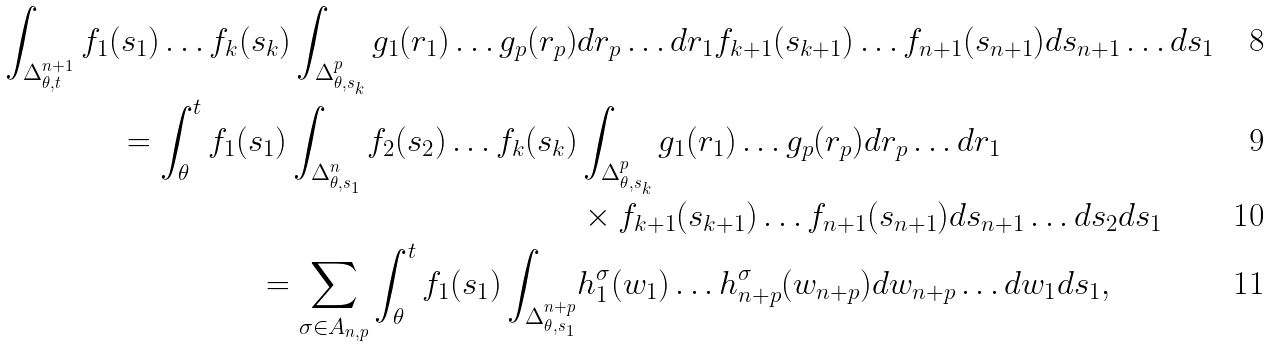Convert formula to latex. <formula><loc_0><loc_0><loc_500><loc_500>\int _ { \Delta _ { \theta , t } ^ { n + 1 } } f _ { 1 } ( s _ { 1 } ) \dots f _ { k } ( s _ { k } ) \int _ { \Delta _ { \theta , s _ { k } } ^ { p } } g _ { 1 } ( r _ { 1 } ) \dots g _ { p } ( r _ { p } ) & d r _ { p } \dots d r _ { 1 } f _ { k + 1 } ( s _ { k + 1 } ) \dots f _ { n + 1 } ( s _ { n + 1 } ) d s _ { n + 1 } \dots d s _ { 1 } \\ = \int _ { \theta } ^ { t } f _ { 1 } ( s _ { 1 } ) \int _ { \Delta _ { \theta , s _ { 1 } } ^ { n } } f _ { 2 } ( s _ { 2 } ) \dots f _ { k } ( s _ { k } ) & \int _ { \Delta _ { \theta , s _ { k } } ^ { p } } g _ { 1 } ( r _ { 1 } ) \dots g _ { p } ( r _ { p } ) d r _ { p } \dots d r _ { 1 } \\ & \times f _ { k + 1 } ( s _ { k + 1 } ) \dots f _ { n + 1 } ( s _ { n + 1 } ) d s _ { n + 1 } \dots d s _ { 2 } d s _ { 1 } \\ = \sum _ { \sigma \in A _ { n , p } } \int _ { \theta } ^ { t } f _ { 1 } ( s _ { 1 } ) \int _ { \Delta _ { \theta , s _ { 1 } } ^ { n + p } } & h _ { 1 } ^ { \sigma } ( w _ { 1 } ) \dots h _ { n + p } ^ { \sigma } ( w _ { n + p } ) d w _ { n + p } \dots d w _ { 1 } d s _ { 1 } ,</formula> 